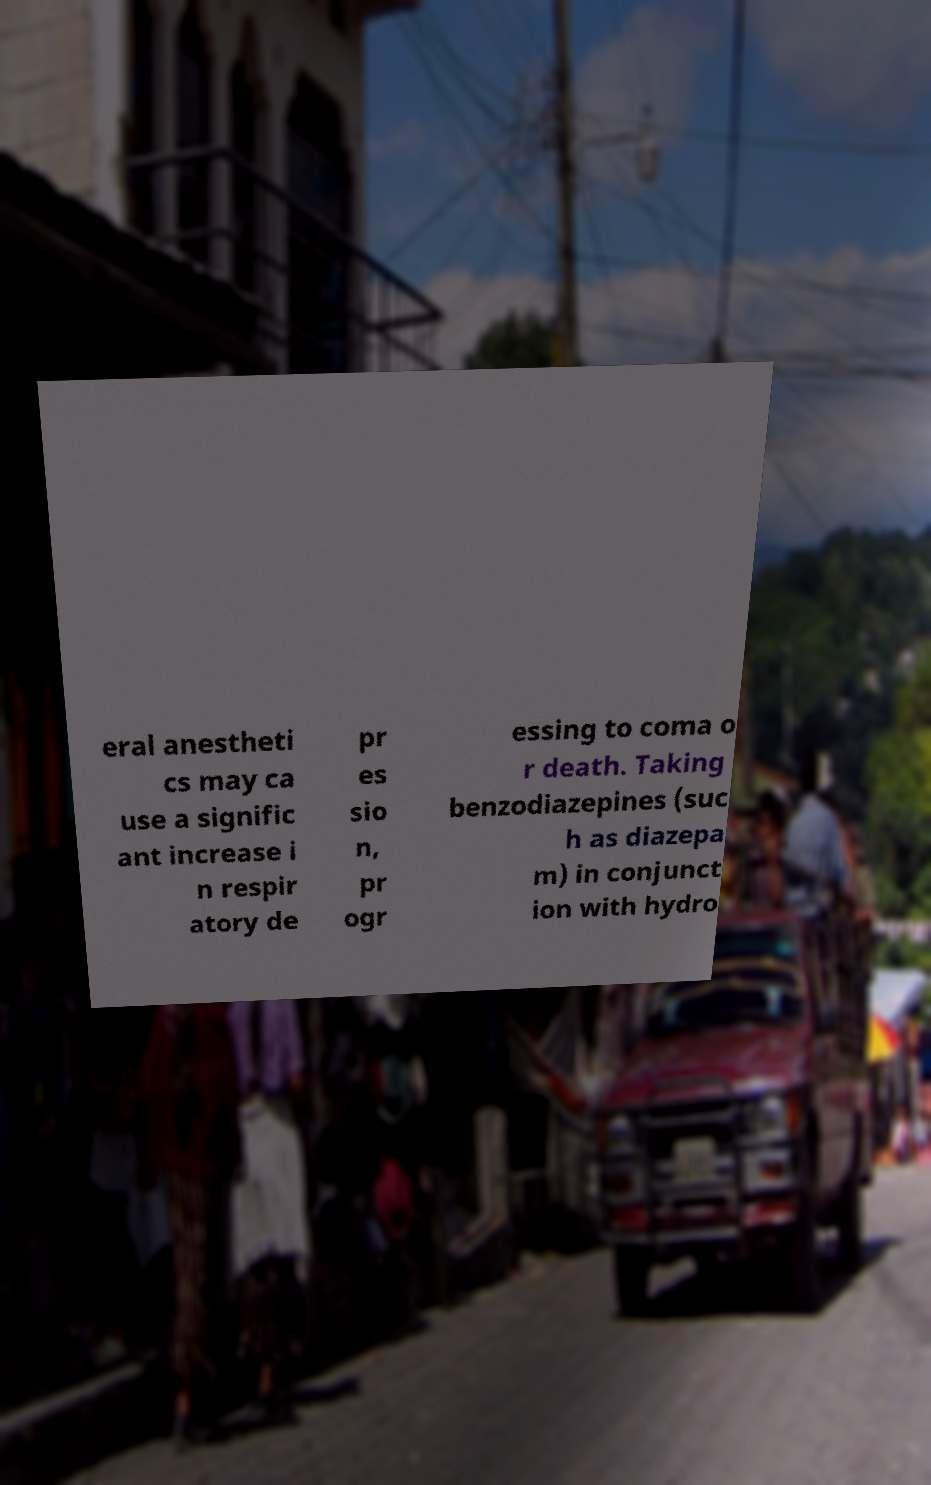I need the written content from this picture converted into text. Can you do that? eral anestheti cs may ca use a signific ant increase i n respir atory de pr es sio n, pr ogr essing to coma o r death. Taking benzodiazepines (suc h as diazepa m) in conjunct ion with hydro 